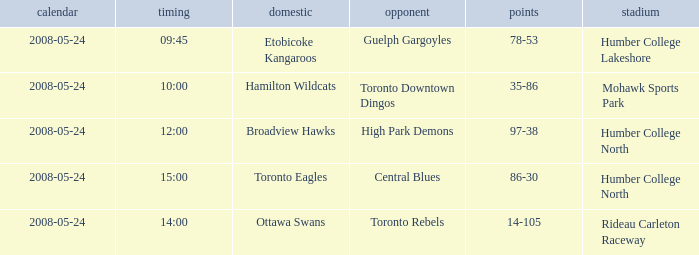Could you parse the entire table as a dict? {'header': ['calendar', 'timing', 'domestic', 'opponent', 'points', 'stadium'], 'rows': [['2008-05-24', '09:45', 'Etobicoke Kangaroos', 'Guelph Gargoyles', '78-53', 'Humber College Lakeshore'], ['2008-05-24', '10:00', 'Hamilton Wildcats', 'Toronto Downtown Dingos', '35-86', 'Mohawk Sports Park'], ['2008-05-24', '12:00', 'Broadview Hawks', 'High Park Demons', '97-38', 'Humber College North'], ['2008-05-24', '15:00', 'Toronto Eagles', 'Central Blues', '86-30', 'Humber College North'], ['2008-05-24', '14:00', 'Ottawa Swans', 'Toronto Rebels', '14-105', 'Rideau Carleton Raceway']]} What was the playing field for the toronto rebels' away team? Rideau Carleton Raceway. 